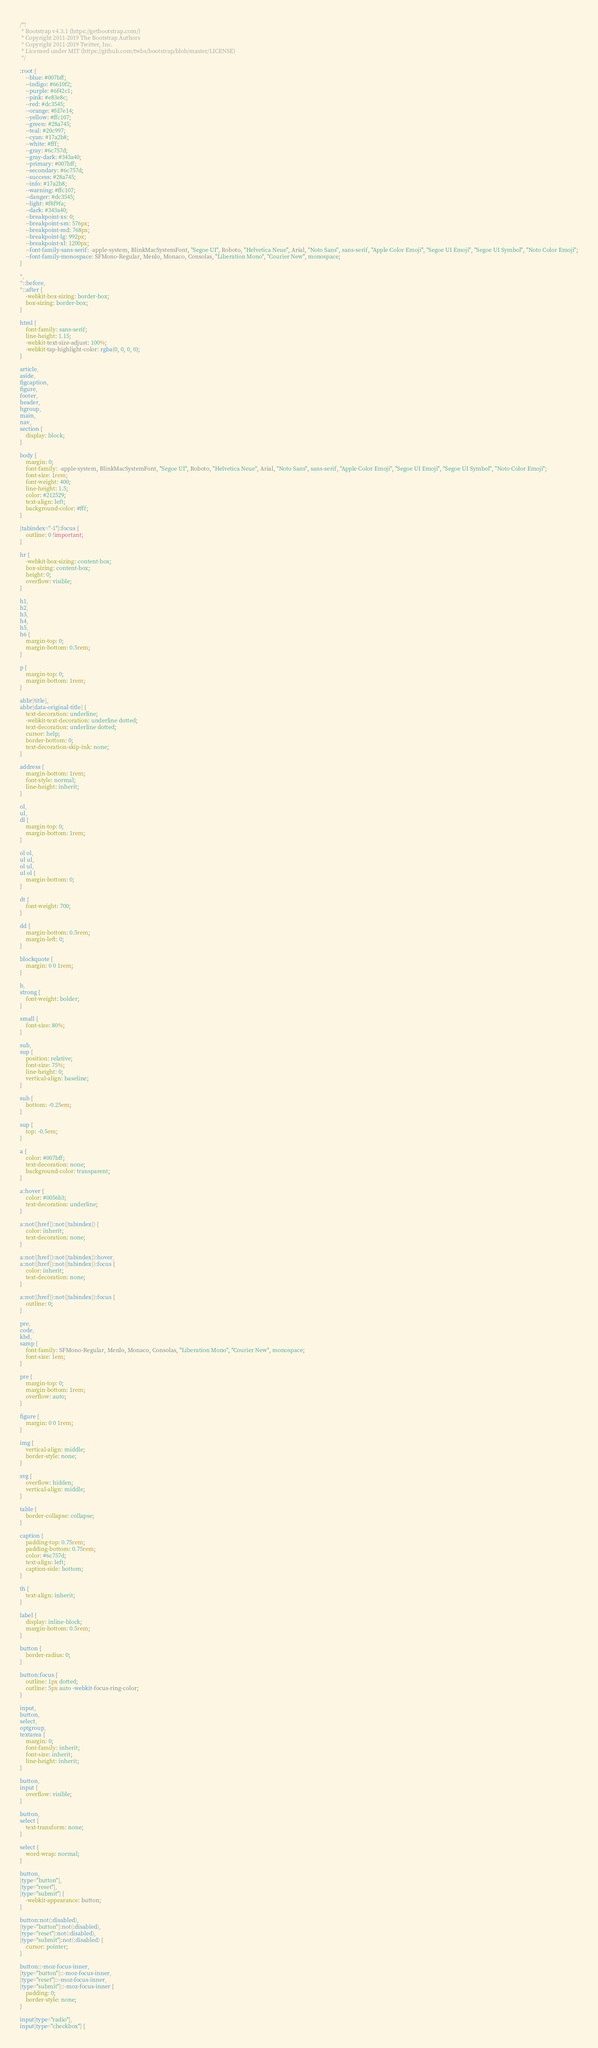Convert code to text. <code><loc_0><loc_0><loc_500><loc_500><_CSS_>/*!
 * Bootstrap v4.3.1 (https://getbootstrap.com/)
 * Copyright 2011-2019 The Bootstrap Authors
 * Copyright 2011-2019 Twitter, Inc.
 * Licensed under MIT (https://github.com/twbs/bootstrap/blob/master/LICENSE)
 */

:root {
    --blue: #007bff;
    --indigo: #6610f2;
    --purple: #6f42c1;
    --pink: #e83e8c;
    --red: #dc3545;
    --orange: #fd7e14;
    --yellow: #ffc107;
    --green: #28a745;
    --teal: #20c997;
    --cyan: #17a2b8;
    --white: #fff;
    --gray: #6c757d;
    --gray-dark: #343a40;
    --primary: #007bff;
    --secondary: #6c757d;
    --success: #28a745;
    --info: #17a2b8;
    --warning: #ffc107;
    --danger: #dc3545;
    --light: #f8f9fa;
    --dark: #343a40;
    --breakpoint-xs: 0;
    --breakpoint-sm: 576px;
    --breakpoint-md: 768px;
    --breakpoint-lg: 992px;
    --breakpoint-xl: 1200px;
    --font-family-sans-serif: -apple-system, BlinkMacSystemFont, "Segoe UI", Roboto, "Helvetica Neue", Arial, "Noto Sans", sans-serif, "Apple Color Emoji", "Segoe UI Emoji", "Segoe UI Symbol", "Noto Color Emoji";
    --font-family-monospace: SFMono-Regular, Menlo, Monaco, Consolas, "Liberation Mono", "Courier New", monospace;
}

*,
*::before,
*::after {
    -webkit-box-sizing: border-box;
    box-sizing: border-box;
}

html {
    font-family: sans-serif;
    line-height: 1.15;
    -webkit-text-size-adjust: 100%;
    -webkit-tap-highlight-color: rgba(0, 0, 0, 0);
}

article,
aside,
figcaption,
figure,
footer,
header,
hgroup,
main,
nav,
section {
    display: block;
}

body {
    margin: 0;
    font-family: -apple-system, BlinkMacSystemFont, "Segoe UI", Roboto, "Helvetica Neue", Arial, "Noto Sans", sans-serif, "Apple Color Emoji", "Segoe UI Emoji", "Segoe UI Symbol", "Noto Color Emoji";
    font-size: 1rem;
    font-weight: 400;
    line-height: 1.5;
    color: #212529;
    text-align: left;
    background-color: #fff;
}

[tabindex="-1"]:focus {
    outline: 0 !important;
}

hr {
    -webkit-box-sizing: content-box;
    box-sizing: content-box;
    height: 0;
    overflow: visible;
}

h1,
h2,
h3,
h4,
h5,
h6 {
    margin-top: 0;
    margin-bottom: 0.5rem;
}

p {
    margin-top: 0;
    margin-bottom: 1rem;
}

abbr[title],
abbr[data-original-title] {
    text-decoration: underline;
    -webkit-text-decoration: underline dotted;
    text-decoration: underline dotted;
    cursor: help;
    border-bottom: 0;
    text-decoration-skip-ink: none;
}

address {
    margin-bottom: 1rem;
    font-style: normal;
    line-height: inherit;
}

ol,
ul,
dl {
    margin-top: 0;
    margin-bottom: 1rem;
}

ol ol,
ul ul,
ol ul,
ul ol {
    margin-bottom: 0;
}

dt {
    font-weight: 700;
}

dd {
    margin-bottom: 0.5rem;
    margin-left: 0;
}

blockquote {
    margin: 0 0 1rem;
}

b,
strong {
    font-weight: bolder;
}

small {
    font-size: 80%;
}

sub,
sup {
    position: relative;
    font-size: 75%;
    line-height: 0;
    vertical-align: baseline;
}

sub {
    bottom: -0.25em;
}

sup {
    top: -0.5em;
}

a {
    color: #007bff;
    text-decoration: none;
    background-color: transparent;
}

a:hover {
    color: #0056b3;
    text-decoration: underline;
}

a:not([href]):not([tabindex]) {
    color: inherit;
    text-decoration: none;
}

a:not([href]):not([tabindex]):hover,
a:not([href]):not([tabindex]):focus {
    color: inherit;
    text-decoration: none;
}

a:not([href]):not([tabindex]):focus {
    outline: 0;
}

pre,
code,
kbd,
samp {
    font-family: SFMono-Regular, Menlo, Monaco, Consolas, "Liberation Mono", "Courier New", monospace;
    font-size: 1em;
}

pre {
    margin-top: 0;
    margin-bottom: 1rem;
    overflow: auto;
}

figure {
    margin: 0 0 1rem;
}

img {
    vertical-align: middle;
    border-style: none;
}

svg {
    overflow: hidden;
    vertical-align: middle;
}

table {
    border-collapse: collapse;
}

caption {
    padding-top: 0.75rem;
    padding-bottom: 0.75rem;
    color: #6c757d;
    text-align: left;
    caption-side: bottom;
}

th {
    text-align: inherit;
}

label {
    display: inline-block;
    margin-bottom: 0.5rem;
}

button {
    border-radius: 0;
}

button:focus {
    outline: 1px dotted;
    outline: 5px auto -webkit-focus-ring-color;
}

input,
button,
select,
optgroup,
textarea {
    margin: 0;
    font-family: inherit;
    font-size: inherit;
    line-height: inherit;
}

button,
input {
    overflow: visible;
}

button,
select {
    text-transform: none;
}

select {
    word-wrap: normal;
}

button,
[type="button"],
[type="reset"],
[type="submit"] {
    -webkit-appearance: button;
}

button:not(:disabled),
[type="button"]:not(:disabled),
[type="reset"]:not(:disabled),
[type="submit"]:not(:disabled) {
    cursor: pointer;
}

button::-moz-focus-inner,
[type="button"]::-moz-focus-inner,
[type="reset"]::-moz-focus-inner,
[type="submit"]::-moz-focus-inner {
    padding: 0;
    border-style: none;
}

input[type="radio"],
input[type="checkbox"] {</code> 